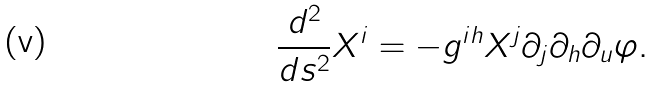Convert formula to latex. <formula><loc_0><loc_0><loc_500><loc_500>\frac { d ^ { 2 } } { d s ^ { 2 } } X ^ { i } = - g ^ { i h } X ^ { j } \partial _ { j } \partial _ { h } \partial _ { u } \varphi .</formula> 